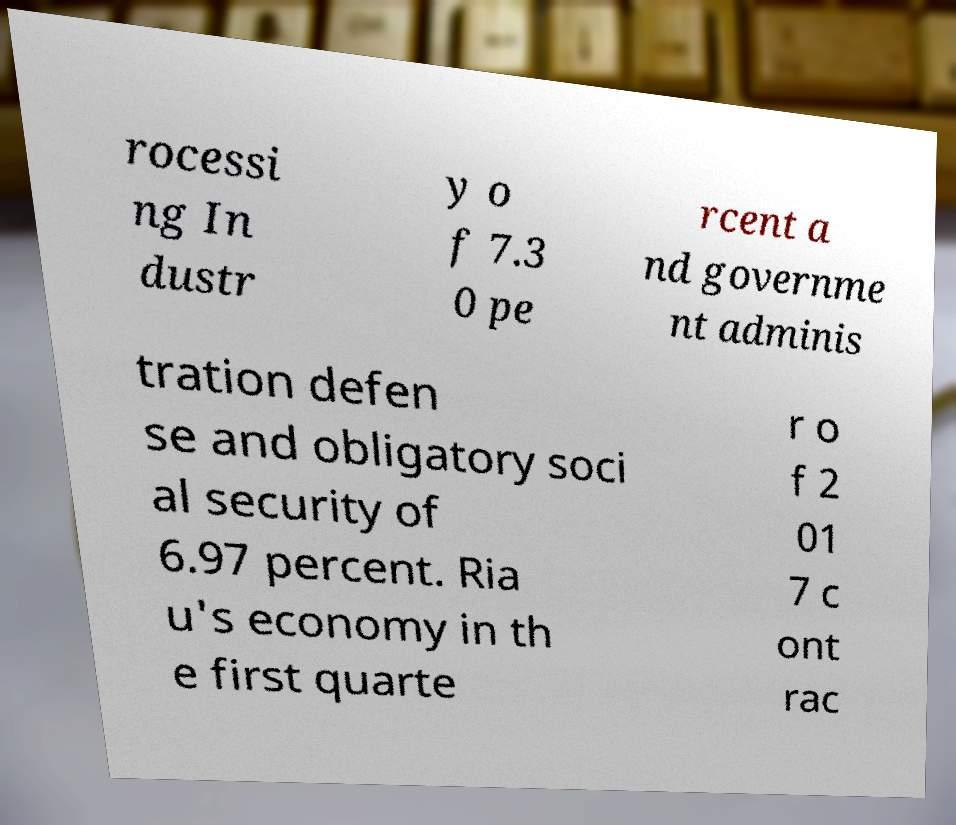There's text embedded in this image that I need extracted. Can you transcribe it verbatim? rocessi ng In dustr y o f 7.3 0 pe rcent a nd governme nt adminis tration defen se and obligatory soci al security of 6.97 percent. Ria u's economy in th e first quarte r o f 2 01 7 c ont rac 